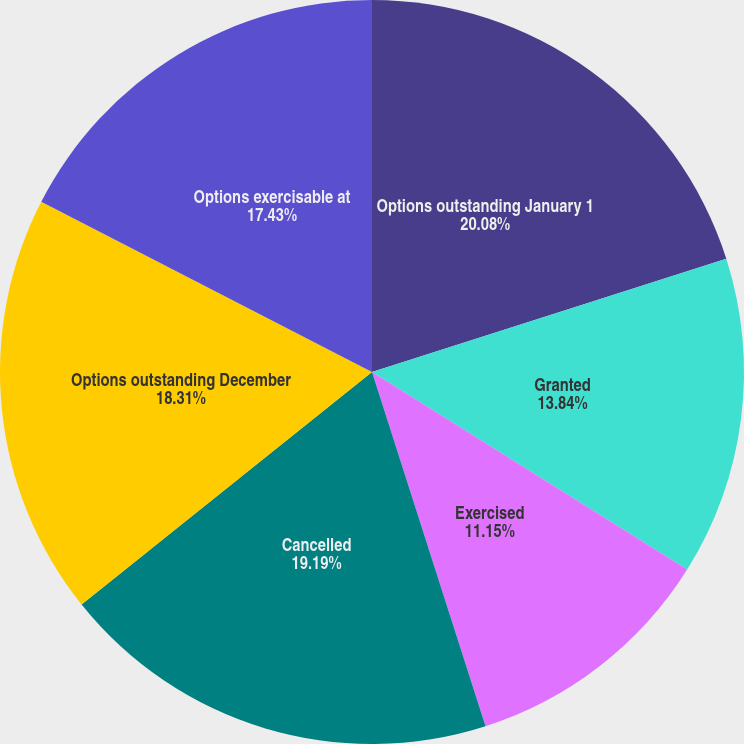Convert chart to OTSL. <chart><loc_0><loc_0><loc_500><loc_500><pie_chart><fcel>Options outstanding January 1<fcel>Granted<fcel>Exercised<fcel>Cancelled<fcel>Options outstanding December<fcel>Options exercisable at<nl><fcel>20.07%<fcel>13.84%<fcel>11.15%<fcel>19.19%<fcel>18.31%<fcel>17.43%<nl></chart> 